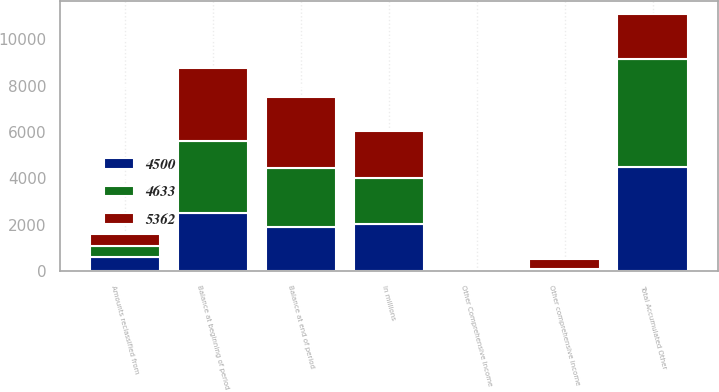Convert chart to OTSL. <chart><loc_0><loc_0><loc_500><loc_500><stacked_bar_chart><ecel><fcel>In millions<fcel>Balance at beginning of period<fcel>Other comprehensive income<fcel>Amounts reclassified from<fcel>Balance at end of period<fcel>Other Comprehensive Income<fcel>Total Accumulated Other<nl><fcel>4500<fcel>2018<fcel>2527<fcel>22<fcel>589<fcel>1916<fcel>3<fcel>4500<nl><fcel>4633<fcel>2017<fcel>3072<fcel>59<fcel>486<fcel>2527<fcel>1<fcel>4633<nl><fcel>5362<fcel>2016<fcel>3169<fcel>448<fcel>545<fcel>3072<fcel>2<fcel>1966<nl></chart> 